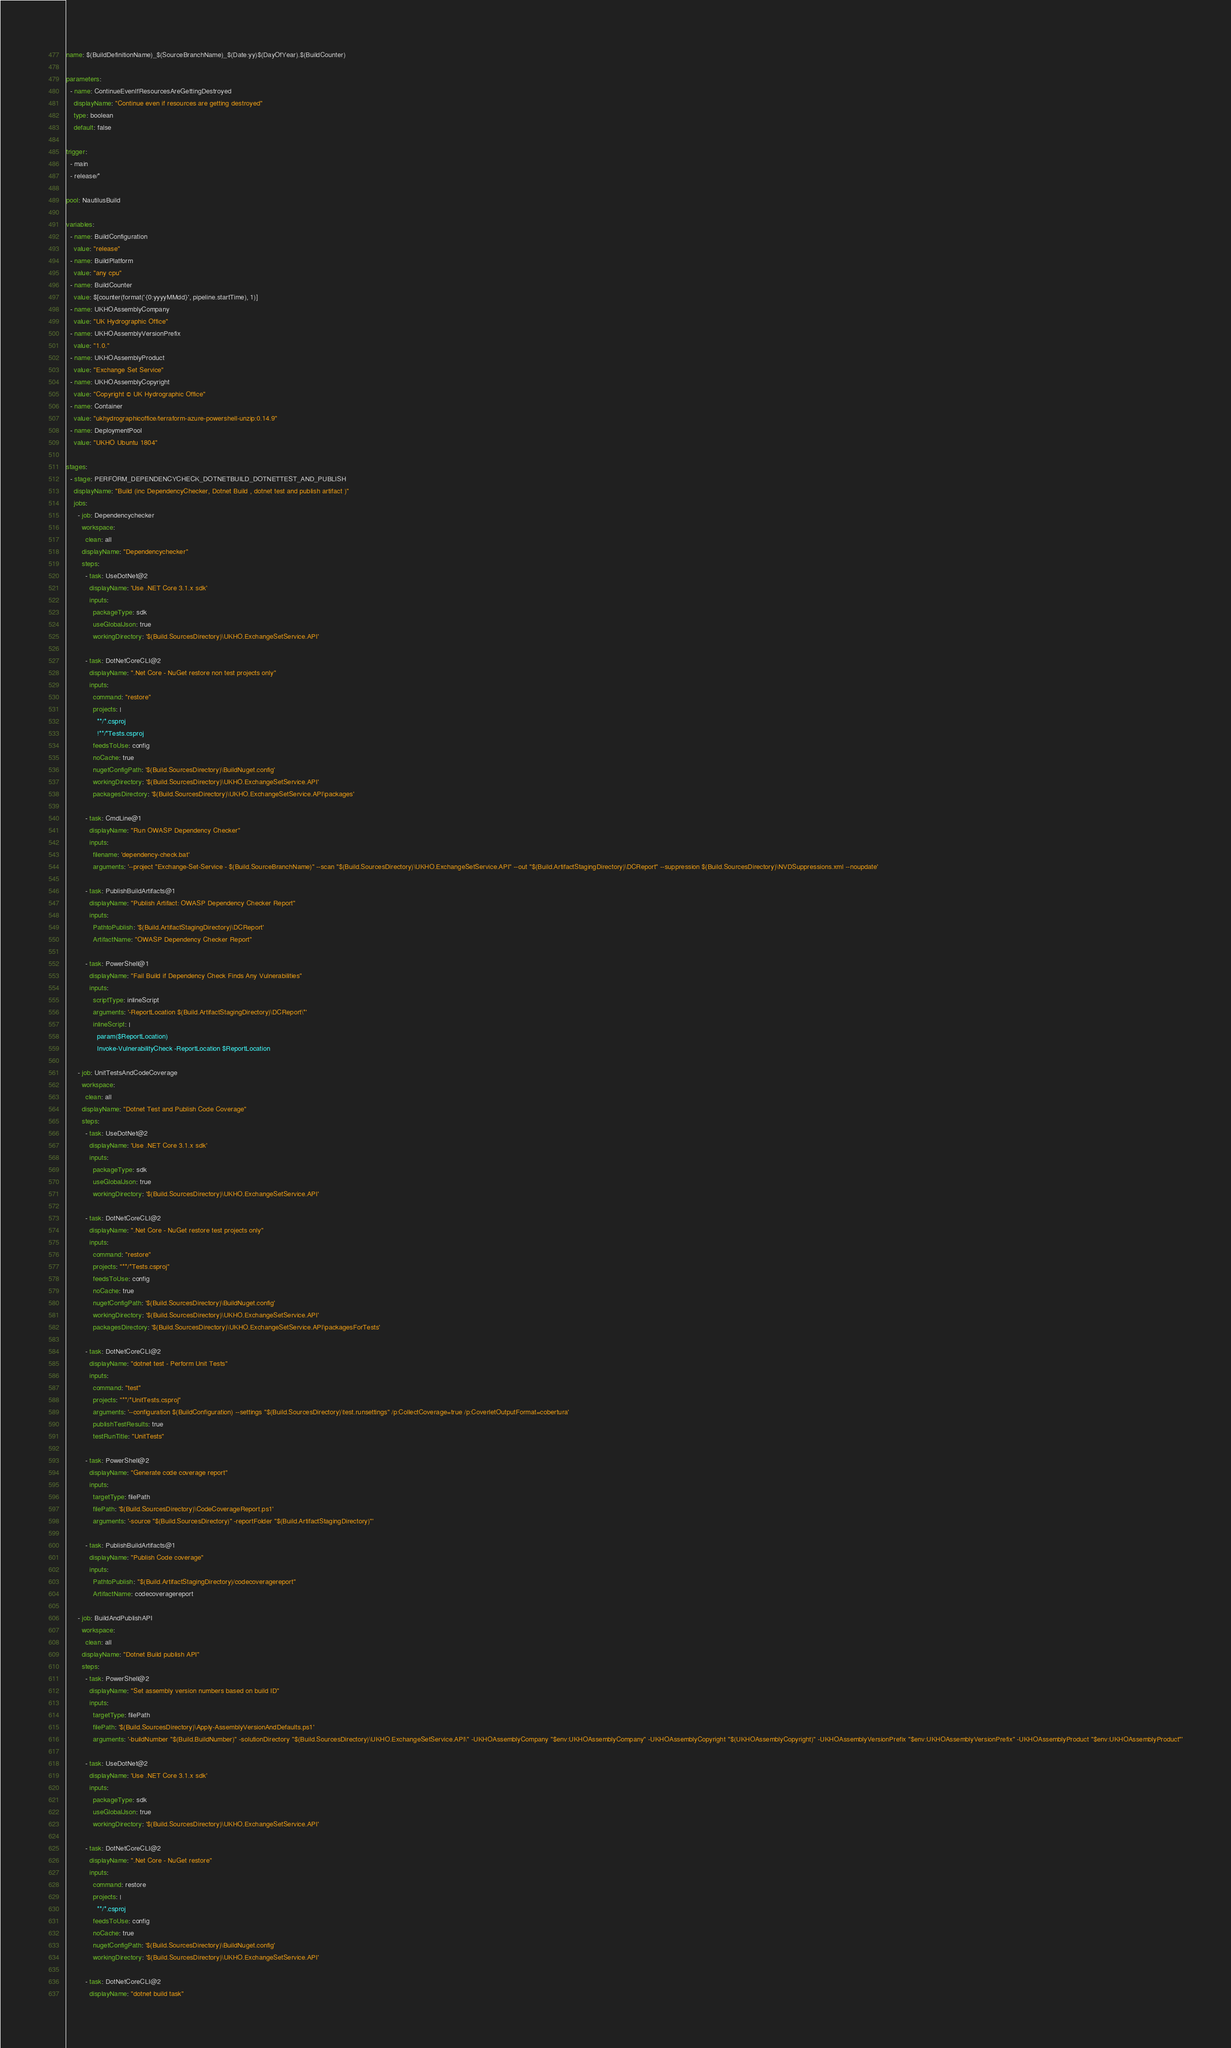<code> <loc_0><loc_0><loc_500><loc_500><_YAML_>name: $(BuildDefinitionName)_$(SourceBranchName)_$(Date:yy)$(DayOfYear).$(BuildCounter)

parameters:
  - name: ContinueEvenIfResourcesAreGettingDestroyed
    displayName: "Continue even if resources are getting destroyed"
    type: boolean
    default: false

trigger:
  - main
  - release/*

pool: NautilusBuild

variables:
  - name: BuildConfiguration
    value: "release"
  - name: BuildPlatform
    value: "any cpu"
  - name: BuildCounter
    value: $[counter(format('{0:yyyyMMdd}', pipeline.startTime), 1)]
  - name: UKHOAssemblyCompany
    value: "UK Hydrographic Office"
  - name: UKHOAssemblyVersionPrefix
    value: "1.0."
  - name: UKHOAssemblyProduct
    value: "Exchange Set Service"
  - name: UKHOAssemblyCopyright
    value: "Copyright © UK Hydrographic Office"
  - name: Container
    value: "ukhydrographicoffice/terraform-azure-powershell-unzip:0.14.9"
  - name: DeploymentPool
    value: "UKHO Ubuntu 1804"

stages:
  - stage: PERFORM_DEPENDENCYCHECK_DOTNETBUILD_DOTNETTEST_AND_PUBLISH
    displayName: "Build (inc DependencyChecker, Dotnet Build , dotnet test and publish artifact )"
    jobs:
      - job: Dependencychecker
        workspace:
          clean: all
        displayName: "Dependencychecker"
        steps:
          - task: UseDotNet@2
            displayName: 'Use .NET Core 3.1.x sdk'
            inputs:
              packageType: sdk
              useGlobalJson: true
              workingDirectory: '$(Build.SourcesDirectory)\UKHO.ExchangeSetService.API'

          - task: DotNetCoreCLI@2
            displayName: ".Net Core - NuGet restore non test projects only"
            inputs:
              command: "restore"
              projects: |
                **/*.csproj
                !**/*Tests.csproj
              feedsToUse: config
              noCache: true
              nugetConfigPath: '$(Build.SourcesDirectory)\BuildNuget.config'
              workingDirectory: '$(Build.SourcesDirectory)\UKHO.ExchangeSetService.API'
              packagesDirectory: '$(Build.SourcesDirectory)\UKHO.ExchangeSetService.API\packages'

          - task: CmdLine@1
            displayName: "Run OWASP Dependency Checker"
            inputs:
              filename: 'dependency-check.bat'
              arguments: '--project "Exchange-Set-Service - $(Build.SourceBranchName)" --scan "$(Build.SourcesDirectory)\UKHO.ExchangeSetService.API" --out "$(Build.ArtifactStagingDirectory)\DCReport" --suppression $(Build.SourcesDirectory)\NVDSuppressions.xml --noupdate'

          - task: PublishBuildArtifacts@1
            displayName: "Publish Artifact: OWASP Dependency Checker Report"
            inputs:
              PathtoPublish: '$(Build.ArtifactStagingDirectory)\DCReport'
              ArtifactName: "OWASP Dependency Checker Report"

          - task: PowerShell@1
            displayName: "Fail Build if Dependency Check Finds Any Vulnerabilities"
            inputs:
              scriptType: inlineScript
              arguments: '-ReportLocation $(Build.ArtifactStagingDirectory)\DCReport\*'
              inlineScript: |
                param($ReportLocation)
                Invoke-VulnerabilityCheck -ReportLocation $ReportLocation

      - job: UnitTestsAndCodeCoverage
        workspace:
          clean: all
        displayName: "Dotnet Test and Publish Code Coverage"
        steps:
          - task: UseDotNet@2
            displayName: 'Use .NET Core 3.1.x sdk'
            inputs:
              packageType: sdk
              useGlobalJson: true
              workingDirectory: '$(Build.SourcesDirectory)\UKHO.ExchangeSetService.API'

          - task: DotNetCoreCLI@2
            displayName: ".Net Core - NuGet restore test projects only"
            inputs:
              command: "restore"
              projects: "**/*Tests.csproj"
              feedsToUse: config
              noCache: true
              nugetConfigPath: '$(Build.SourcesDirectory)\BuildNuget.config'
              workingDirectory: '$(Build.SourcesDirectory)\UKHO.ExchangeSetService.API'
              packagesDirectory: '$(Build.SourcesDirectory)\UKHO.ExchangeSetService.API\packagesForTests'

          - task: DotNetCoreCLI@2
            displayName: "dotnet test - Perform Unit Tests"
            inputs:
              command: "test"
              projects: "**/*UnitTests.csproj"
              arguments: '--configuration $(BuildConfiguration) --settings "$(Build.SourcesDirectory)\test.runsettings" /p:CollectCoverage=true /p:CoverletOutputFormat=cobertura'
              publishTestResults: true
              testRunTitle: "UnitTests"

          - task: PowerShell@2
            displayName: "Generate code coverage report"
            inputs:
              targetType: filePath
              filePath: '$(Build.SourcesDirectory)\CodeCoverageReport.ps1'
              arguments: '-source "$(Build.SourcesDirectory)" -reportFolder "$(Build.ArtifactStagingDirectory)"'

          - task: PublishBuildArtifacts@1
            displayName: "Publish Code coverage"
            inputs:
              PathtoPublish: "$(Build.ArtifactStagingDirectory)/codecoveragereport"
              ArtifactName: codecoveragereport

      - job: BuildAndPublishAPI
        workspace:
          clean: all
        displayName: "Dotnet Build publish API"
        steps:
          - task: PowerShell@2
            displayName: "Set assembly version numbers based on build ID"
            inputs:
              targetType: filePath
              filePath: '$(Build.SourcesDirectory)\Apply-AssemblyVersionAndDefaults.ps1'
              arguments: '-buildNumber "$(Build.BuildNumber)" -solutionDirectory "$(Build.SourcesDirectory)\UKHO.ExchangeSetService.API\" -UKHOAssemblyCompany "$env:UKHOAssemblyCompany" -UKHOAssemblyCopyright "$(UKHOAssemblyCopyright)" -UKHOAssemblyVersionPrefix "$env:UKHOAssemblyVersionPrefix" -UKHOAssemblyProduct "$env:UKHOAssemblyProduct"'

          - task: UseDotNet@2
            displayName: 'Use .NET Core 3.1.x sdk'
            inputs:
              packageType: sdk
              useGlobalJson: true
              workingDirectory: '$(Build.SourcesDirectory)\UKHO.ExchangeSetService.API'

          - task: DotNetCoreCLI@2
            displayName: ".Net Core - NuGet restore"
            inputs:
              command: restore
              projects: |
                **/*.csproj
              feedsToUse: config
              noCache: true
              nugetConfigPath: '$(Build.SourcesDirectory)\BuildNuget.config'
              workingDirectory: '$(Build.SourcesDirectory)\UKHO.ExchangeSetService.API'

          - task: DotNetCoreCLI@2
            displayName: "dotnet build task"</code> 